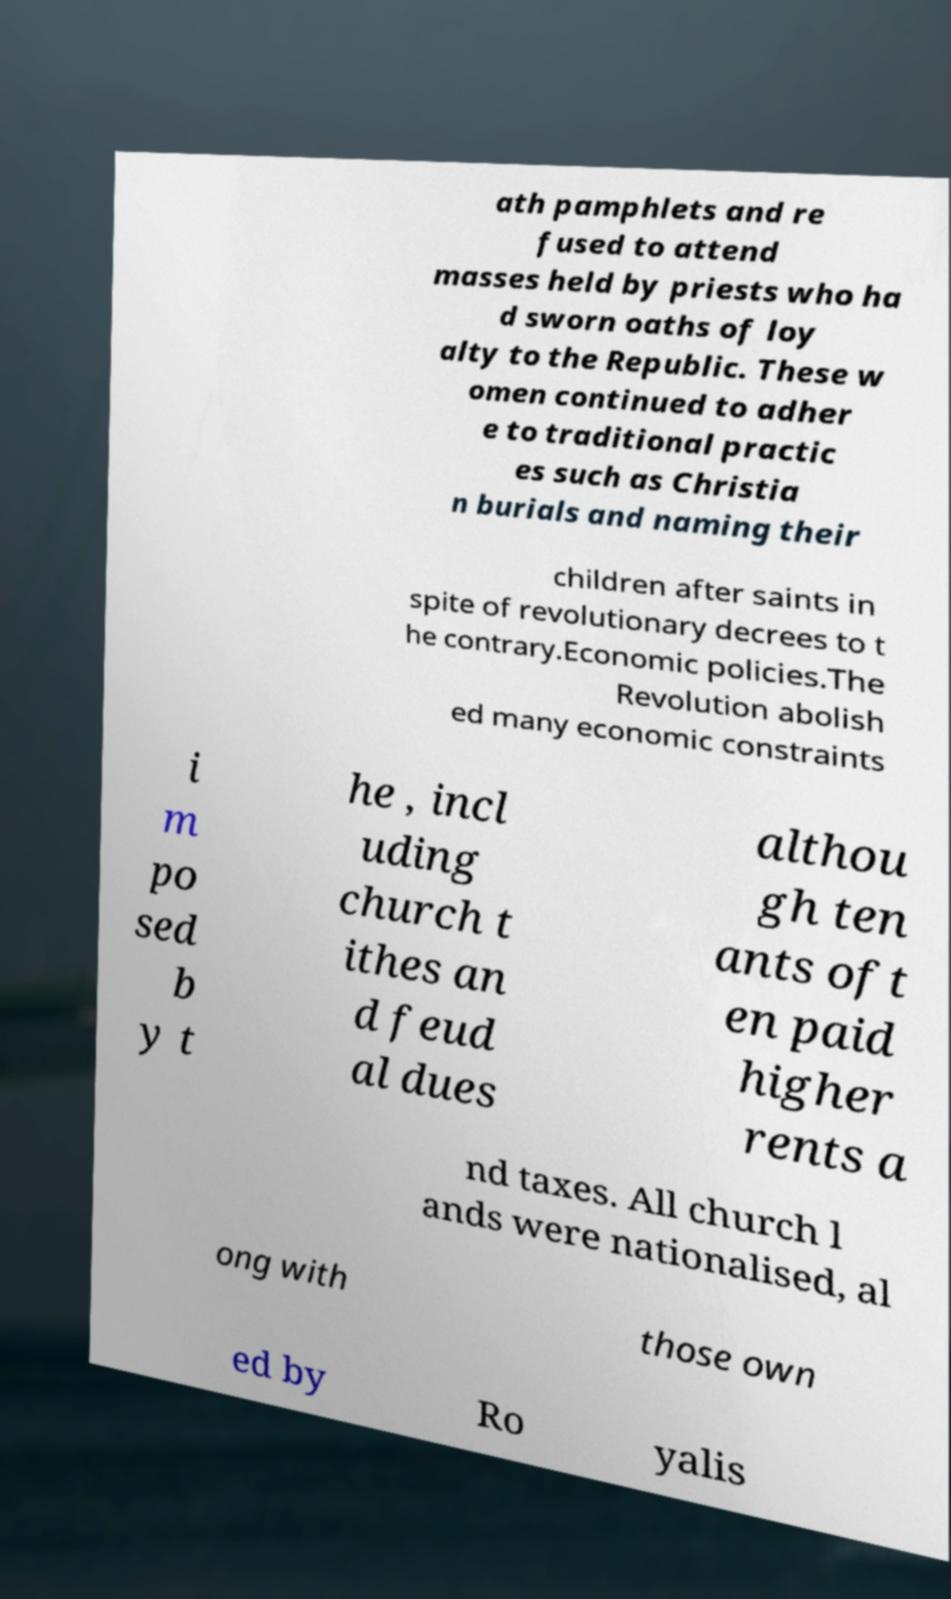There's text embedded in this image that I need extracted. Can you transcribe it verbatim? ath pamphlets and re fused to attend masses held by priests who ha d sworn oaths of loy alty to the Republic. These w omen continued to adher e to traditional practic es such as Christia n burials and naming their children after saints in spite of revolutionary decrees to t he contrary.Economic policies.The Revolution abolish ed many economic constraints i m po sed b y t he , incl uding church t ithes an d feud al dues althou gh ten ants oft en paid higher rents a nd taxes. All church l ands were nationalised, al ong with those own ed by Ro yalis 